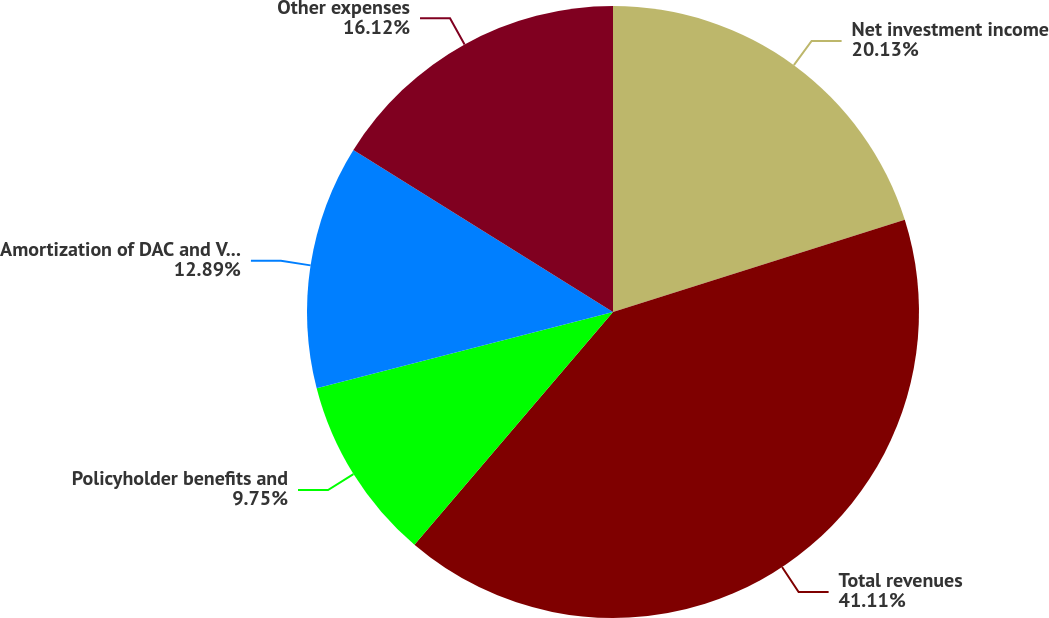<chart> <loc_0><loc_0><loc_500><loc_500><pie_chart><fcel>Net investment income<fcel>Total revenues<fcel>Policyholder benefits and<fcel>Amortization of DAC and VOBA<fcel>Other expenses<nl><fcel>20.13%<fcel>41.11%<fcel>9.75%<fcel>12.89%<fcel>16.12%<nl></chart> 